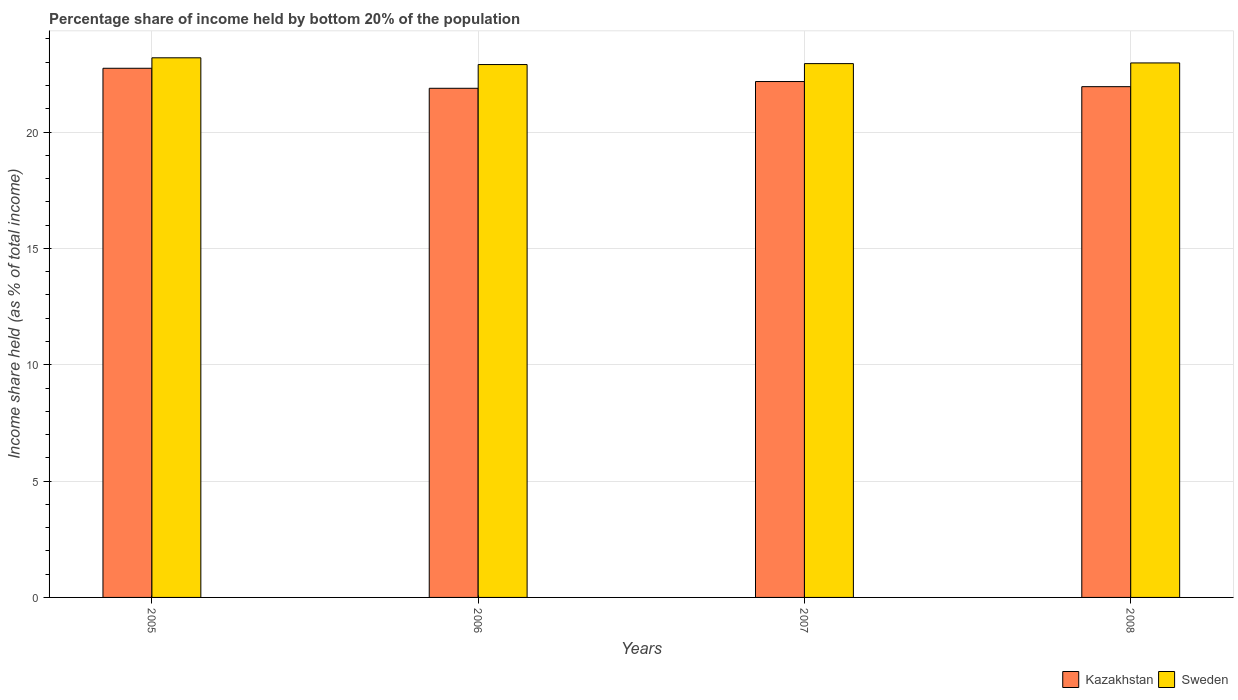How many different coloured bars are there?
Keep it short and to the point. 2. Are the number of bars per tick equal to the number of legend labels?
Provide a succinct answer. Yes. Are the number of bars on each tick of the X-axis equal?
Your response must be concise. Yes. How many bars are there on the 1st tick from the right?
Keep it short and to the point. 2. What is the label of the 1st group of bars from the left?
Provide a short and direct response. 2005. In how many cases, is the number of bars for a given year not equal to the number of legend labels?
Your answer should be compact. 0. What is the share of income held by bottom 20% of the population in Kazakhstan in 2008?
Make the answer very short. 21.95. Across all years, what is the maximum share of income held by bottom 20% of the population in Kazakhstan?
Offer a very short reply. 22.74. Across all years, what is the minimum share of income held by bottom 20% of the population in Sweden?
Make the answer very short. 22.9. In which year was the share of income held by bottom 20% of the population in Kazakhstan minimum?
Make the answer very short. 2006. What is the total share of income held by bottom 20% of the population in Kazakhstan in the graph?
Your response must be concise. 88.74. What is the difference between the share of income held by bottom 20% of the population in Kazakhstan in 2006 and that in 2007?
Keep it short and to the point. -0.29. What is the difference between the share of income held by bottom 20% of the population in Kazakhstan in 2008 and the share of income held by bottom 20% of the population in Sweden in 2006?
Offer a very short reply. -0.95. What is the average share of income held by bottom 20% of the population in Kazakhstan per year?
Make the answer very short. 22.18. In the year 2005, what is the difference between the share of income held by bottom 20% of the population in Kazakhstan and share of income held by bottom 20% of the population in Sweden?
Your response must be concise. -0.45. What is the ratio of the share of income held by bottom 20% of the population in Sweden in 2007 to that in 2008?
Your response must be concise. 1. Is the share of income held by bottom 20% of the population in Sweden in 2005 less than that in 2006?
Ensure brevity in your answer.  No. What is the difference between the highest and the second highest share of income held by bottom 20% of the population in Kazakhstan?
Offer a very short reply. 0.57. What is the difference between the highest and the lowest share of income held by bottom 20% of the population in Kazakhstan?
Give a very brief answer. 0.86. What does the 1st bar from the left in 2006 represents?
Give a very brief answer. Kazakhstan. What does the 2nd bar from the right in 2008 represents?
Keep it short and to the point. Kazakhstan. How many bars are there?
Give a very brief answer. 8. What is the difference between two consecutive major ticks on the Y-axis?
Give a very brief answer. 5. Are the values on the major ticks of Y-axis written in scientific E-notation?
Provide a succinct answer. No. How many legend labels are there?
Make the answer very short. 2. What is the title of the graph?
Provide a succinct answer. Percentage share of income held by bottom 20% of the population. Does "Cameroon" appear as one of the legend labels in the graph?
Your answer should be very brief. No. What is the label or title of the Y-axis?
Your answer should be compact. Income share held (as % of total income). What is the Income share held (as % of total income) of Kazakhstan in 2005?
Keep it short and to the point. 22.74. What is the Income share held (as % of total income) in Sweden in 2005?
Keep it short and to the point. 23.19. What is the Income share held (as % of total income) in Kazakhstan in 2006?
Your answer should be very brief. 21.88. What is the Income share held (as % of total income) of Sweden in 2006?
Give a very brief answer. 22.9. What is the Income share held (as % of total income) in Kazakhstan in 2007?
Your answer should be very brief. 22.17. What is the Income share held (as % of total income) of Sweden in 2007?
Your response must be concise. 22.94. What is the Income share held (as % of total income) of Kazakhstan in 2008?
Provide a short and direct response. 21.95. What is the Income share held (as % of total income) of Sweden in 2008?
Provide a succinct answer. 22.97. Across all years, what is the maximum Income share held (as % of total income) of Kazakhstan?
Your answer should be compact. 22.74. Across all years, what is the maximum Income share held (as % of total income) in Sweden?
Ensure brevity in your answer.  23.19. Across all years, what is the minimum Income share held (as % of total income) in Kazakhstan?
Give a very brief answer. 21.88. Across all years, what is the minimum Income share held (as % of total income) in Sweden?
Make the answer very short. 22.9. What is the total Income share held (as % of total income) of Kazakhstan in the graph?
Your response must be concise. 88.74. What is the total Income share held (as % of total income) in Sweden in the graph?
Provide a short and direct response. 92. What is the difference between the Income share held (as % of total income) in Kazakhstan in 2005 and that in 2006?
Provide a short and direct response. 0.86. What is the difference between the Income share held (as % of total income) in Sweden in 2005 and that in 2006?
Your answer should be very brief. 0.29. What is the difference between the Income share held (as % of total income) in Kazakhstan in 2005 and that in 2007?
Your answer should be compact. 0.57. What is the difference between the Income share held (as % of total income) in Kazakhstan in 2005 and that in 2008?
Your response must be concise. 0.79. What is the difference between the Income share held (as % of total income) in Sweden in 2005 and that in 2008?
Make the answer very short. 0.22. What is the difference between the Income share held (as % of total income) in Kazakhstan in 2006 and that in 2007?
Provide a short and direct response. -0.29. What is the difference between the Income share held (as % of total income) in Sweden in 2006 and that in 2007?
Make the answer very short. -0.04. What is the difference between the Income share held (as % of total income) in Kazakhstan in 2006 and that in 2008?
Provide a succinct answer. -0.07. What is the difference between the Income share held (as % of total income) of Sweden in 2006 and that in 2008?
Your answer should be compact. -0.07. What is the difference between the Income share held (as % of total income) in Kazakhstan in 2007 and that in 2008?
Keep it short and to the point. 0.22. What is the difference between the Income share held (as % of total income) in Sweden in 2007 and that in 2008?
Offer a terse response. -0.03. What is the difference between the Income share held (as % of total income) in Kazakhstan in 2005 and the Income share held (as % of total income) in Sweden in 2006?
Make the answer very short. -0.16. What is the difference between the Income share held (as % of total income) of Kazakhstan in 2005 and the Income share held (as % of total income) of Sweden in 2008?
Keep it short and to the point. -0.23. What is the difference between the Income share held (as % of total income) of Kazakhstan in 2006 and the Income share held (as % of total income) of Sweden in 2007?
Make the answer very short. -1.06. What is the difference between the Income share held (as % of total income) in Kazakhstan in 2006 and the Income share held (as % of total income) in Sweden in 2008?
Offer a very short reply. -1.09. What is the difference between the Income share held (as % of total income) in Kazakhstan in 2007 and the Income share held (as % of total income) in Sweden in 2008?
Offer a very short reply. -0.8. What is the average Income share held (as % of total income) in Kazakhstan per year?
Provide a short and direct response. 22.18. In the year 2005, what is the difference between the Income share held (as % of total income) in Kazakhstan and Income share held (as % of total income) in Sweden?
Offer a very short reply. -0.45. In the year 2006, what is the difference between the Income share held (as % of total income) in Kazakhstan and Income share held (as % of total income) in Sweden?
Offer a terse response. -1.02. In the year 2007, what is the difference between the Income share held (as % of total income) of Kazakhstan and Income share held (as % of total income) of Sweden?
Give a very brief answer. -0.77. In the year 2008, what is the difference between the Income share held (as % of total income) in Kazakhstan and Income share held (as % of total income) in Sweden?
Offer a terse response. -1.02. What is the ratio of the Income share held (as % of total income) of Kazakhstan in 2005 to that in 2006?
Make the answer very short. 1.04. What is the ratio of the Income share held (as % of total income) of Sweden in 2005 to that in 2006?
Keep it short and to the point. 1.01. What is the ratio of the Income share held (as % of total income) in Kazakhstan in 2005 to that in 2007?
Provide a succinct answer. 1.03. What is the ratio of the Income share held (as % of total income) in Sweden in 2005 to that in 2007?
Your answer should be very brief. 1.01. What is the ratio of the Income share held (as % of total income) of Kazakhstan in 2005 to that in 2008?
Keep it short and to the point. 1.04. What is the ratio of the Income share held (as % of total income) in Sweden in 2005 to that in 2008?
Provide a short and direct response. 1.01. What is the ratio of the Income share held (as % of total income) in Kazakhstan in 2006 to that in 2007?
Ensure brevity in your answer.  0.99. What is the ratio of the Income share held (as % of total income) of Sweden in 2006 to that in 2007?
Keep it short and to the point. 1. What is the ratio of the Income share held (as % of total income) in Kazakhstan in 2006 to that in 2008?
Your response must be concise. 1. What is the ratio of the Income share held (as % of total income) in Kazakhstan in 2007 to that in 2008?
Offer a terse response. 1.01. What is the ratio of the Income share held (as % of total income) of Sweden in 2007 to that in 2008?
Give a very brief answer. 1. What is the difference between the highest and the second highest Income share held (as % of total income) in Kazakhstan?
Provide a succinct answer. 0.57. What is the difference between the highest and the second highest Income share held (as % of total income) of Sweden?
Offer a very short reply. 0.22. What is the difference between the highest and the lowest Income share held (as % of total income) of Kazakhstan?
Provide a succinct answer. 0.86. What is the difference between the highest and the lowest Income share held (as % of total income) in Sweden?
Your answer should be very brief. 0.29. 